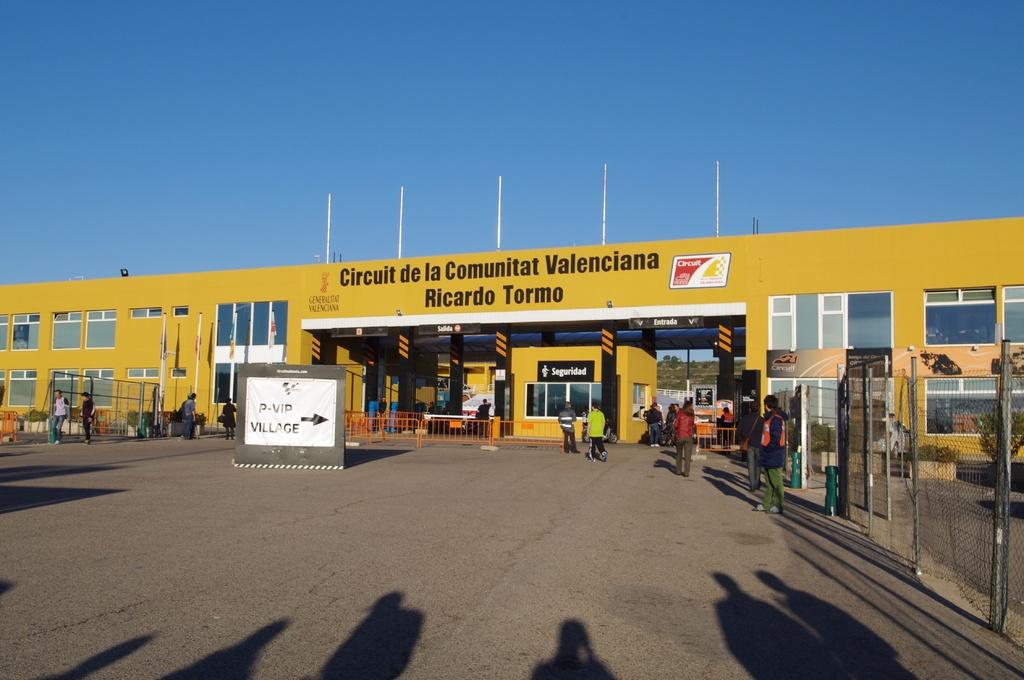What is the name of this buliding?
Provide a succinct answer. Circuit de la comunitat valenciana. 